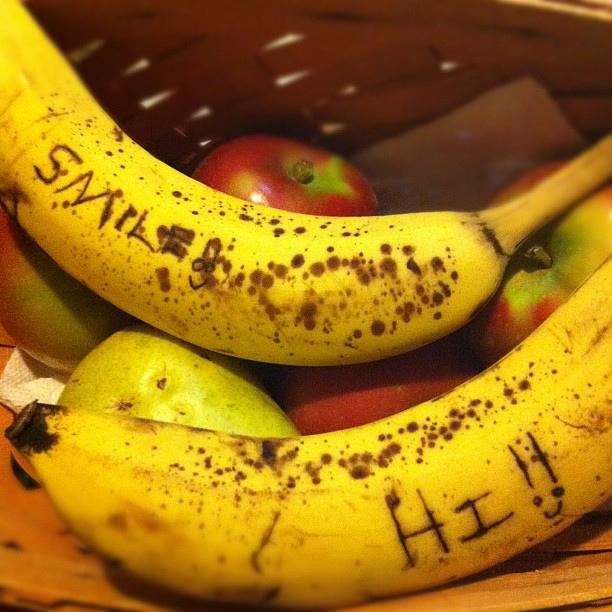What is on the fruit?

Choices:
A) ants
B) flies
C) writing
D) mold writing 